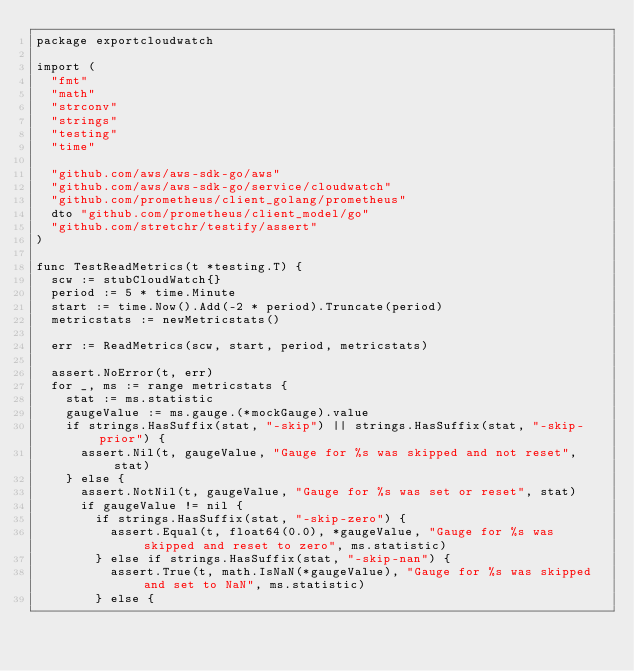Convert code to text. <code><loc_0><loc_0><loc_500><loc_500><_Go_>package exportcloudwatch

import (
	"fmt"
	"math"
	"strconv"
	"strings"
	"testing"
	"time"

	"github.com/aws/aws-sdk-go/aws"
	"github.com/aws/aws-sdk-go/service/cloudwatch"
	"github.com/prometheus/client_golang/prometheus"
	dto "github.com/prometheus/client_model/go"
	"github.com/stretchr/testify/assert"
)

func TestReadMetrics(t *testing.T) {
	scw := stubCloudWatch{}
	period := 5 * time.Minute
	start := time.Now().Add(-2 * period).Truncate(period)
	metricstats := newMetricstats()

	err := ReadMetrics(scw, start, period, metricstats)

	assert.NoError(t, err)
	for _, ms := range metricstats {
		stat := ms.statistic
		gaugeValue := ms.gauge.(*mockGauge).value
		if strings.HasSuffix(stat, "-skip") || strings.HasSuffix(stat, "-skip-prior") {
			assert.Nil(t, gaugeValue, "Gauge for %s was skipped and not reset", stat)
		} else {
			assert.NotNil(t, gaugeValue, "Gauge for %s was set or reset", stat)
			if gaugeValue != nil {
				if strings.HasSuffix(stat, "-skip-zero") {
					assert.Equal(t, float64(0.0), *gaugeValue, "Gauge for %s was skipped and reset to zero", ms.statistic)
				} else if strings.HasSuffix(stat, "-skip-nan") {
					assert.True(t, math.IsNaN(*gaugeValue), "Gauge for %s was skipped and set to NaN", ms.statistic)
				} else {</code> 